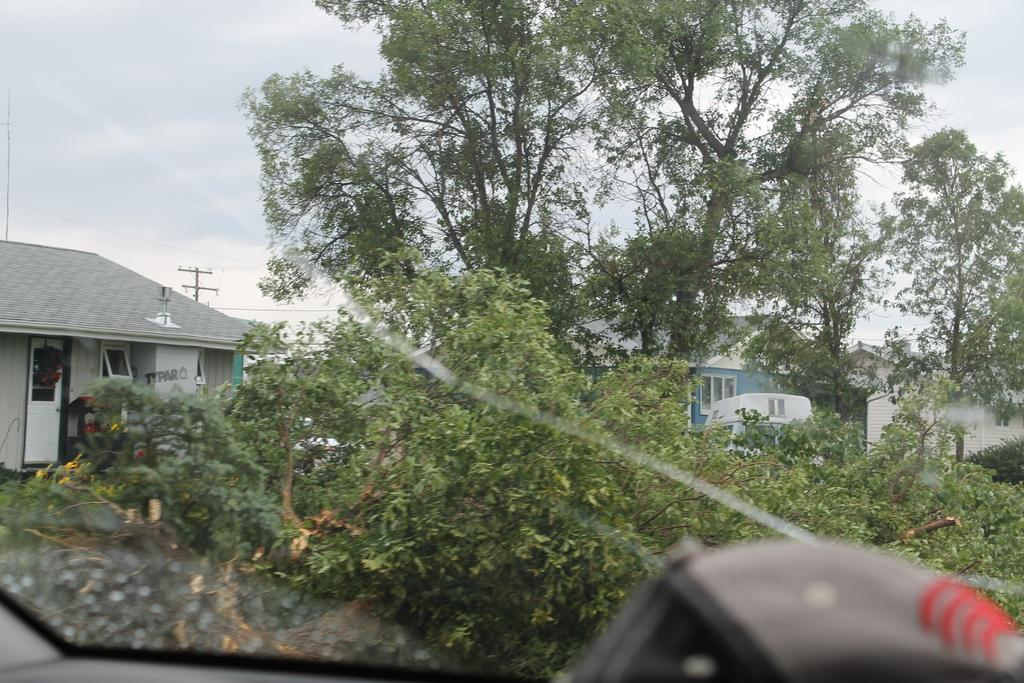What type of structures can be seen in the image? There are buildings in the image. What other natural elements are present in the image? There are trees in the image. What man-made object can be seen in the image? There is an electric pole in the image. What is connected to the electric pole? There are electric cables in the image. What part of the natural environment is visible in the image? The sky is visible in the image. What can be observed in the sky? Clouds are present in the sky. From where is the view of the image taken? The view is through a motor vehicle's window. What number is associated with the drug that is being discussed in the image? There is no drug or number mentioned in the image; it features buildings, trees, an electric pole, electric cables, the sky, clouds, and a view through a motor vehicle's window. How does the mind of the person in the image appear to be affected by the situation? There is no person or situation depicted in the image that would allow us to assess the state of their mind. 